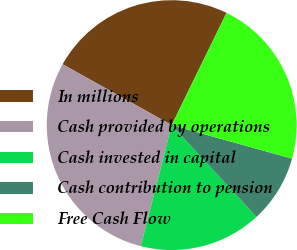Convert chart. <chart><loc_0><loc_0><loc_500><loc_500><pie_chart><fcel>In millions<fcel>Cash provided by operations<fcel>Cash invested in capital<fcel>Cash contribution to pension<fcel>Free Cash Flow<nl><fcel>24.13%<fcel>29.12%<fcel>15.84%<fcel>8.81%<fcel>22.09%<nl></chart> 